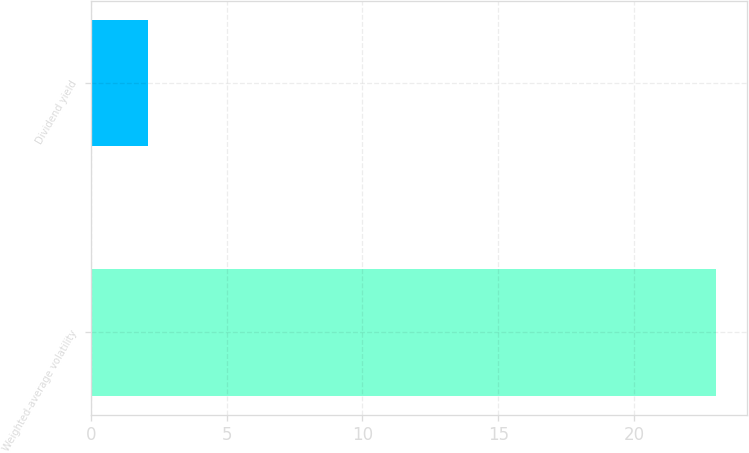Convert chart to OTSL. <chart><loc_0><loc_0><loc_500><loc_500><bar_chart><fcel>Weighted-average volatility<fcel>Dividend yield<nl><fcel>23<fcel>2.11<nl></chart> 